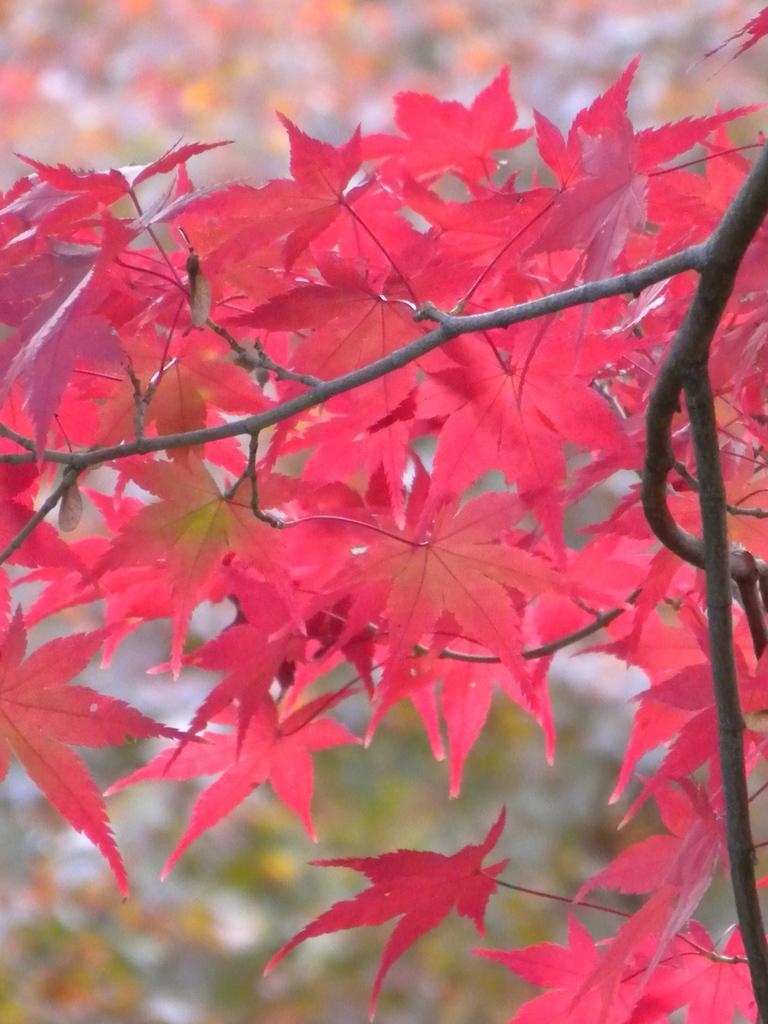Describe this image in one or two sentences. In this image there is a plant, there are leaves, the background of the image is blurred. 